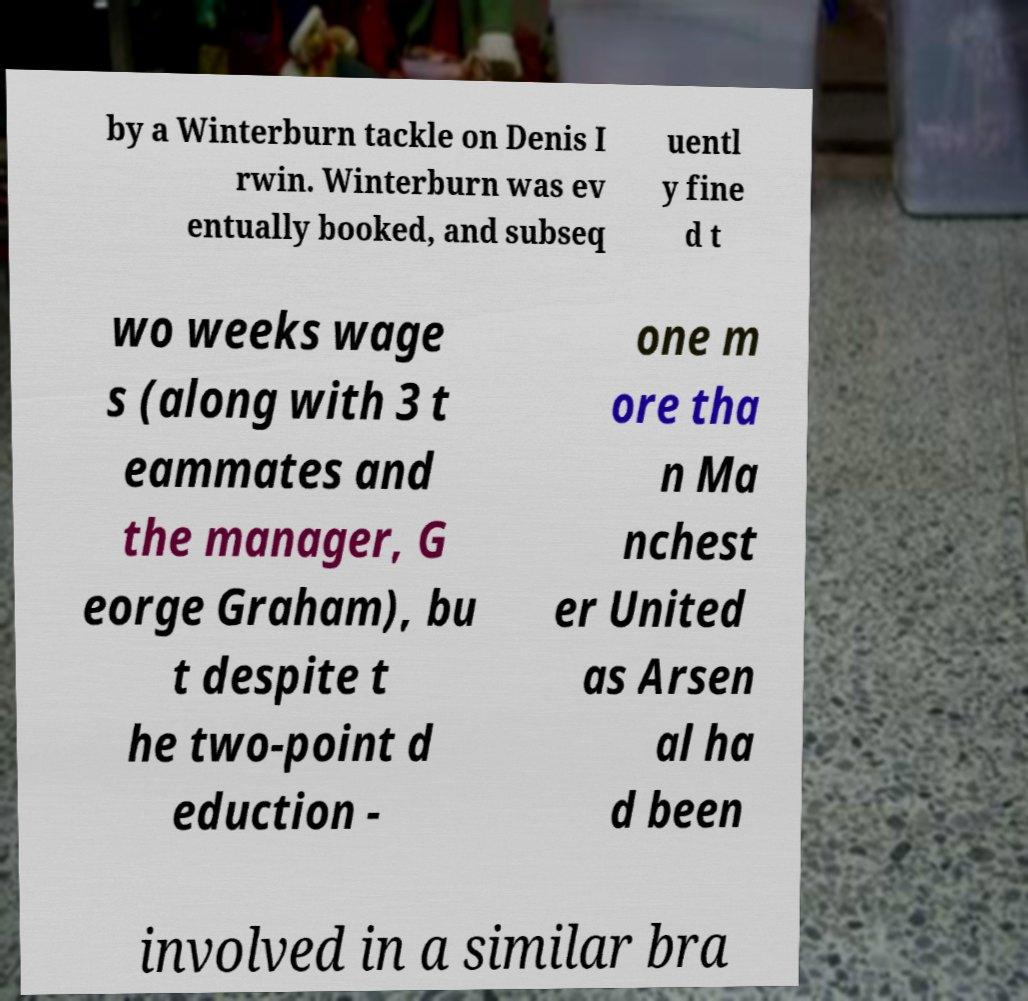What messages or text are displayed in this image? I need them in a readable, typed format. by a Winterburn tackle on Denis I rwin. Winterburn was ev entually booked, and subseq uentl y fine d t wo weeks wage s (along with 3 t eammates and the manager, G eorge Graham), bu t despite t he two-point d eduction - one m ore tha n Ma nchest er United as Arsen al ha d been involved in a similar bra 